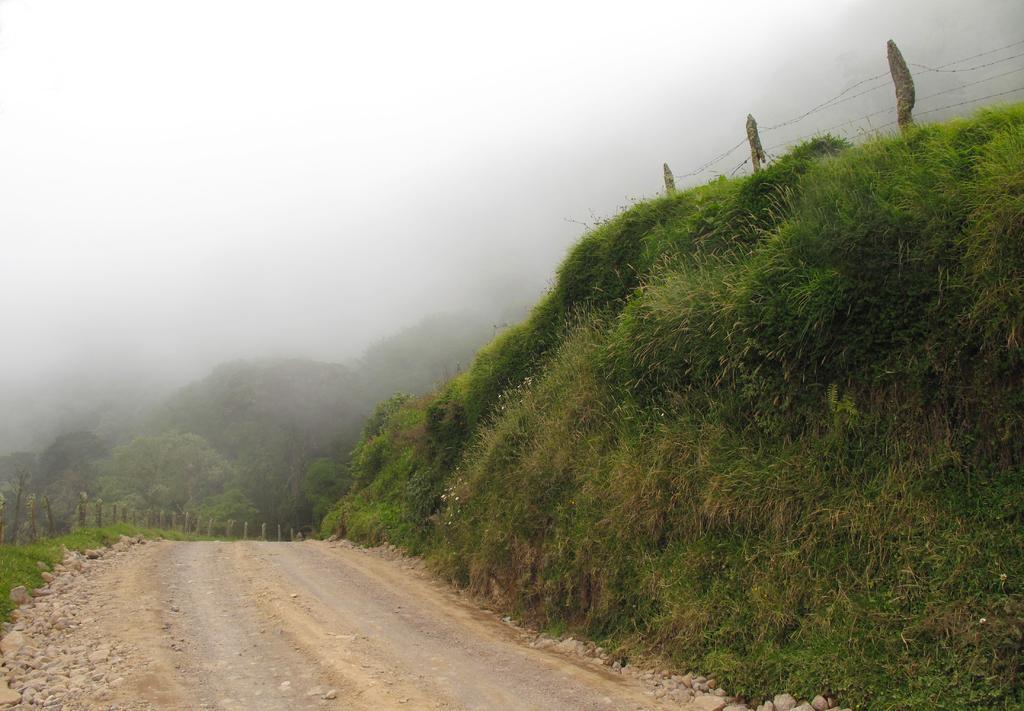In one or two sentences, can you explain what this image depicts? In the center of the image there is road. To the left side of the image there is grass. In the background of the image there are trees. 